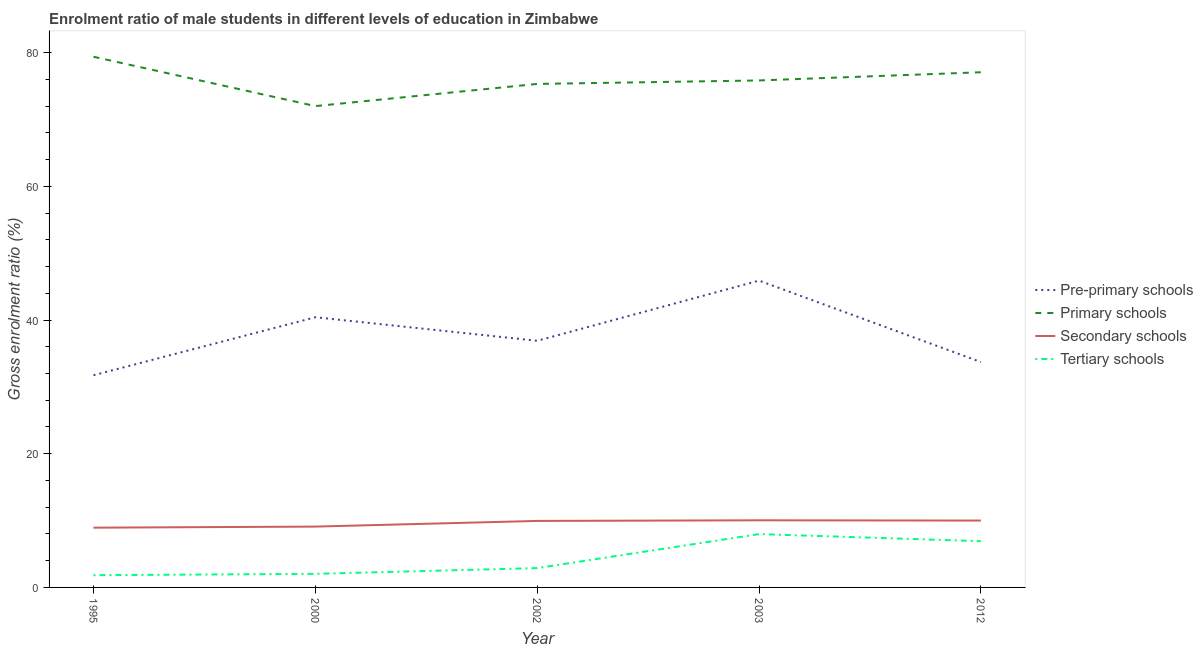How many different coloured lines are there?
Your response must be concise. 4. Is the number of lines equal to the number of legend labels?
Make the answer very short. Yes. What is the gross enrolment ratio(female) in tertiary schools in 2000?
Provide a succinct answer. 2.03. Across all years, what is the maximum gross enrolment ratio(female) in tertiary schools?
Offer a very short reply. 7.98. Across all years, what is the minimum gross enrolment ratio(female) in pre-primary schools?
Ensure brevity in your answer.  31.74. What is the total gross enrolment ratio(female) in secondary schools in the graph?
Offer a very short reply. 48.03. What is the difference between the gross enrolment ratio(female) in secondary schools in 1995 and that in 2012?
Your answer should be compact. -1.06. What is the difference between the gross enrolment ratio(female) in pre-primary schools in 2002 and the gross enrolment ratio(female) in tertiary schools in 2003?
Provide a succinct answer. 28.92. What is the average gross enrolment ratio(female) in secondary schools per year?
Keep it short and to the point. 9.61. In the year 1995, what is the difference between the gross enrolment ratio(female) in secondary schools and gross enrolment ratio(female) in primary schools?
Offer a terse response. -70.44. In how many years, is the gross enrolment ratio(female) in pre-primary schools greater than 28 %?
Keep it short and to the point. 5. What is the ratio of the gross enrolment ratio(female) in pre-primary schools in 2000 to that in 2012?
Your answer should be very brief. 1.2. Is the gross enrolment ratio(female) in primary schools in 2003 less than that in 2012?
Offer a terse response. Yes. Is the difference between the gross enrolment ratio(female) in tertiary schools in 1995 and 2002 greater than the difference between the gross enrolment ratio(female) in pre-primary schools in 1995 and 2002?
Provide a succinct answer. Yes. What is the difference between the highest and the second highest gross enrolment ratio(female) in primary schools?
Provide a short and direct response. 2.32. What is the difference between the highest and the lowest gross enrolment ratio(female) in secondary schools?
Provide a short and direct response. 1.1. In how many years, is the gross enrolment ratio(female) in secondary schools greater than the average gross enrolment ratio(female) in secondary schools taken over all years?
Your answer should be very brief. 3. Is the sum of the gross enrolment ratio(female) in tertiary schools in 2002 and 2003 greater than the maximum gross enrolment ratio(female) in primary schools across all years?
Provide a succinct answer. No. Is it the case that in every year, the sum of the gross enrolment ratio(female) in pre-primary schools and gross enrolment ratio(female) in primary schools is greater than the gross enrolment ratio(female) in secondary schools?
Provide a short and direct response. Yes. Is the gross enrolment ratio(female) in tertiary schools strictly greater than the gross enrolment ratio(female) in primary schools over the years?
Provide a succinct answer. No. How many lines are there?
Make the answer very short. 4. How many years are there in the graph?
Provide a succinct answer. 5. What is the difference between two consecutive major ticks on the Y-axis?
Provide a succinct answer. 20. Does the graph contain any zero values?
Your answer should be very brief. No. Where does the legend appear in the graph?
Ensure brevity in your answer.  Center right. How are the legend labels stacked?
Keep it short and to the point. Vertical. What is the title of the graph?
Keep it short and to the point. Enrolment ratio of male students in different levels of education in Zimbabwe. Does "Budget management" appear as one of the legend labels in the graph?
Ensure brevity in your answer.  No. What is the label or title of the X-axis?
Your response must be concise. Year. What is the label or title of the Y-axis?
Keep it short and to the point. Gross enrolment ratio (%). What is the Gross enrolment ratio (%) in Pre-primary schools in 1995?
Make the answer very short. 31.74. What is the Gross enrolment ratio (%) of Primary schools in 1995?
Ensure brevity in your answer.  79.38. What is the Gross enrolment ratio (%) in Secondary schools in 1995?
Keep it short and to the point. 8.94. What is the Gross enrolment ratio (%) in Tertiary schools in 1995?
Give a very brief answer. 1.83. What is the Gross enrolment ratio (%) of Pre-primary schools in 2000?
Give a very brief answer. 40.42. What is the Gross enrolment ratio (%) of Primary schools in 2000?
Provide a succinct answer. 72. What is the Gross enrolment ratio (%) of Secondary schools in 2000?
Provide a short and direct response. 9.1. What is the Gross enrolment ratio (%) in Tertiary schools in 2000?
Provide a succinct answer. 2.03. What is the Gross enrolment ratio (%) of Pre-primary schools in 2002?
Provide a succinct answer. 36.9. What is the Gross enrolment ratio (%) of Primary schools in 2002?
Your answer should be compact. 75.32. What is the Gross enrolment ratio (%) in Secondary schools in 2002?
Your response must be concise. 9.95. What is the Gross enrolment ratio (%) of Tertiary schools in 2002?
Ensure brevity in your answer.  2.89. What is the Gross enrolment ratio (%) of Pre-primary schools in 2003?
Your response must be concise. 45.9. What is the Gross enrolment ratio (%) of Primary schools in 2003?
Ensure brevity in your answer.  75.84. What is the Gross enrolment ratio (%) of Secondary schools in 2003?
Your response must be concise. 10.04. What is the Gross enrolment ratio (%) in Tertiary schools in 2003?
Give a very brief answer. 7.98. What is the Gross enrolment ratio (%) of Pre-primary schools in 2012?
Ensure brevity in your answer.  33.71. What is the Gross enrolment ratio (%) of Primary schools in 2012?
Offer a very short reply. 77.06. What is the Gross enrolment ratio (%) of Secondary schools in 2012?
Provide a succinct answer. 10. What is the Gross enrolment ratio (%) in Tertiary schools in 2012?
Give a very brief answer. 6.92. Across all years, what is the maximum Gross enrolment ratio (%) of Pre-primary schools?
Offer a very short reply. 45.9. Across all years, what is the maximum Gross enrolment ratio (%) of Primary schools?
Make the answer very short. 79.38. Across all years, what is the maximum Gross enrolment ratio (%) of Secondary schools?
Your answer should be very brief. 10.04. Across all years, what is the maximum Gross enrolment ratio (%) of Tertiary schools?
Ensure brevity in your answer.  7.98. Across all years, what is the minimum Gross enrolment ratio (%) of Pre-primary schools?
Your answer should be compact. 31.74. Across all years, what is the minimum Gross enrolment ratio (%) of Primary schools?
Ensure brevity in your answer.  72. Across all years, what is the minimum Gross enrolment ratio (%) of Secondary schools?
Offer a terse response. 8.94. Across all years, what is the minimum Gross enrolment ratio (%) of Tertiary schools?
Provide a succinct answer. 1.83. What is the total Gross enrolment ratio (%) of Pre-primary schools in the graph?
Keep it short and to the point. 188.66. What is the total Gross enrolment ratio (%) of Primary schools in the graph?
Your answer should be compact. 379.6. What is the total Gross enrolment ratio (%) in Secondary schools in the graph?
Your answer should be compact. 48.03. What is the total Gross enrolment ratio (%) in Tertiary schools in the graph?
Provide a succinct answer. 21.65. What is the difference between the Gross enrolment ratio (%) in Pre-primary schools in 1995 and that in 2000?
Offer a terse response. -8.67. What is the difference between the Gross enrolment ratio (%) of Primary schools in 1995 and that in 2000?
Provide a short and direct response. 7.38. What is the difference between the Gross enrolment ratio (%) of Secondary schools in 1995 and that in 2000?
Ensure brevity in your answer.  -0.16. What is the difference between the Gross enrolment ratio (%) in Tertiary schools in 1995 and that in 2000?
Provide a short and direct response. -0.2. What is the difference between the Gross enrolment ratio (%) in Pre-primary schools in 1995 and that in 2002?
Keep it short and to the point. -5.15. What is the difference between the Gross enrolment ratio (%) of Primary schools in 1995 and that in 2002?
Offer a terse response. 4.06. What is the difference between the Gross enrolment ratio (%) in Secondary schools in 1995 and that in 2002?
Give a very brief answer. -1.01. What is the difference between the Gross enrolment ratio (%) in Tertiary schools in 1995 and that in 2002?
Offer a very short reply. -1.06. What is the difference between the Gross enrolment ratio (%) of Pre-primary schools in 1995 and that in 2003?
Offer a very short reply. -14.15. What is the difference between the Gross enrolment ratio (%) in Primary schools in 1995 and that in 2003?
Keep it short and to the point. 3.55. What is the difference between the Gross enrolment ratio (%) in Secondary schools in 1995 and that in 2003?
Provide a succinct answer. -1.1. What is the difference between the Gross enrolment ratio (%) in Tertiary schools in 1995 and that in 2003?
Your answer should be very brief. -6.15. What is the difference between the Gross enrolment ratio (%) in Pre-primary schools in 1995 and that in 2012?
Give a very brief answer. -1.97. What is the difference between the Gross enrolment ratio (%) in Primary schools in 1995 and that in 2012?
Give a very brief answer. 2.32. What is the difference between the Gross enrolment ratio (%) in Secondary schools in 1995 and that in 2012?
Your answer should be very brief. -1.06. What is the difference between the Gross enrolment ratio (%) of Tertiary schools in 1995 and that in 2012?
Make the answer very short. -5.09. What is the difference between the Gross enrolment ratio (%) of Pre-primary schools in 2000 and that in 2002?
Ensure brevity in your answer.  3.52. What is the difference between the Gross enrolment ratio (%) in Primary schools in 2000 and that in 2002?
Your answer should be compact. -3.32. What is the difference between the Gross enrolment ratio (%) in Secondary schools in 2000 and that in 2002?
Your answer should be compact. -0.85. What is the difference between the Gross enrolment ratio (%) in Tertiary schools in 2000 and that in 2002?
Provide a short and direct response. -0.86. What is the difference between the Gross enrolment ratio (%) of Pre-primary schools in 2000 and that in 2003?
Offer a terse response. -5.48. What is the difference between the Gross enrolment ratio (%) of Primary schools in 2000 and that in 2003?
Your answer should be compact. -3.84. What is the difference between the Gross enrolment ratio (%) of Secondary schools in 2000 and that in 2003?
Keep it short and to the point. -0.94. What is the difference between the Gross enrolment ratio (%) in Tertiary schools in 2000 and that in 2003?
Make the answer very short. -5.94. What is the difference between the Gross enrolment ratio (%) in Pre-primary schools in 2000 and that in 2012?
Your response must be concise. 6.7. What is the difference between the Gross enrolment ratio (%) of Primary schools in 2000 and that in 2012?
Your answer should be very brief. -5.06. What is the difference between the Gross enrolment ratio (%) in Secondary schools in 2000 and that in 2012?
Your response must be concise. -0.9. What is the difference between the Gross enrolment ratio (%) in Tertiary schools in 2000 and that in 2012?
Your answer should be compact. -4.88. What is the difference between the Gross enrolment ratio (%) of Pre-primary schools in 2002 and that in 2003?
Provide a short and direct response. -9. What is the difference between the Gross enrolment ratio (%) of Primary schools in 2002 and that in 2003?
Offer a very short reply. -0.52. What is the difference between the Gross enrolment ratio (%) in Secondary schools in 2002 and that in 2003?
Your answer should be compact. -0.09. What is the difference between the Gross enrolment ratio (%) in Tertiary schools in 2002 and that in 2003?
Your answer should be very brief. -5.09. What is the difference between the Gross enrolment ratio (%) of Pre-primary schools in 2002 and that in 2012?
Your answer should be compact. 3.18. What is the difference between the Gross enrolment ratio (%) in Primary schools in 2002 and that in 2012?
Offer a terse response. -1.74. What is the difference between the Gross enrolment ratio (%) in Secondary schools in 2002 and that in 2012?
Your answer should be compact. -0.06. What is the difference between the Gross enrolment ratio (%) in Tertiary schools in 2002 and that in 2012?
Provide a short and direct response. -4.03. What is the difference between the Gross enrolment ratio (%) of Pre-primary schools in 2003 and that in 2012?
Keep it short and to the point. 12.18. What is the difference between the Gross enrolment ratio (%) in Primary schools in 2003 and that in 2012?
Your response must be concise. -1.23. What is the difference between the Gross enrolment ratio (%) in Secondary schools in 2003 and that in 2012?
Your answer should be very brief. 0.04. What is the difference between the Gross enrolment ratio (%) of Tertiary schools in 2003 and that in 2012?
Keep it short and to the point. 1.06. What is the difference between the Gross enrolment ratio (%) in Pre-primary schools in 1995 and the Gross enrolment ratio (%) in Primary schools in 2000?
Offer a very short reply. -40.26. What is the difference between the Gross enrolment ratio (%) of Pre-primary schools in 1995 and the Gross enrolment ratio (%) of Secondary schools in 2000?
Provide a short and direct response. 22.64. What is the difference between the Gross enrolment ratio (%) of Pre-primary schools in 1995 and the Gross enrolment ratio (%) of Tertiary schools in 2000?
Your response must be concise. 29.71. What is the difference between the Gross enrolment ratio (%) of Primary schools in 1995 and the Gross enrolment ratio (%) of Secondary schools in 2000?
Provide a short and direct response. 70.28. What is the difference between the Gross enrolment ratio (%) in Primary schools in 1995 and the Gross enrolment ratio (%) in Tertiary schools in 2000?
Provide a short and direct response. 77.35. What is the difference between the Gross enrolment ratio (%) in Secondary schools in 1995 and the Gross enrolment ratio (%) in Tertiary schools in 2000?
Provide a short and direct response. 6.91. What is the difference between the Gross enrolment ratio (%) of Pre-primary schools in 1995 and the Gross enrolment ratio (%) of Primary schools in 2002?
Provide a succinct answer. -43.58. What is the difference between the Gross enrolment ratio (%) in Pre-primary schools in 1995 and the Gross enrolment ratio (%) in Secondary schools in 2002?
Your answer should be very brief. 21.8. What is the difference between the Gross enrolment ratio (%) of Pre-primary schools in 1995 and the Gross enrolment ratio (%) of Tertiary schools in 2002?
Your response must be concise. 28.85. What is the difference between the Gross enrolment ratio (%) in Primary schools in 1995 and the Gross enrolment ratio (%) in Secondary schools in 2002?
Provide a short and direct response. 69.44. What is the difference between the Gross enrolment ratio (%) in Primary schools in 1995 and the Gross enrolment ratio (%) in Tertiary schools in 2002?
Provide a succinct answer. 76.49. What is the difference between the Gross enrolment ratio (%) of Secondary schools in 1995 and the Gross enrolment ratio (%) of Tertiary schools in 2002?
Provide a short and direct response. 6.05. What is the difference between the Gross enrolment ratio (%) of Pre-primary schools in 1995 and the Gross enrolment ratio (%) of Primary schools in 2003?
Your response must be concise. -44.09. What is the difference between the Gross enrolment ratio (%) in Pre-primary schools in 1995 and the Gross enrolment ratio (%) in Secondary schools in 2003?
Your answer should be compact. 21.7. What is the difference between the Gross enrolment ratio (%) in Pre-primary schools in 1995 and the Gross enrolment ratio (%) in Tertiary schools in 2003?
Provide a succinct answer. 23.77. What is the difference between the Gross enrolment ratio (%) of Primary schools in 1995 and the Gross enrolment ratio (%) of Secondary schools in 2003?
Your answer should be compact. 69.34. What is the difference between the Gross enrolment ratio (%) in Primary schools in 1995 and the Gross enrolment ratio (%) in Tertiary schools in 2003?
Your answer should be very brief. 71.41. What is the difference between the Gross enrolment ratio (%) of Secondary schools in 1995 and the Gross enrolment ratio (%) of Tertiary schools in 2003?
Offer a terse response. 0.96. What is the difference between the Gross enrolment ratio (%) of Pre-primary schools in 1995 and the Gross enrolment ratio (%) of Primary schools in 2012?
Offer a very short reply. -45.32. What is the difference between the Gross enrolment ratio (%) in Pre-primary schools in 1995 and the Gross enrolment ratio (%) in Secondary schools in 2012?
Ensure brevity in your answer.  21.74. What is the difference between the Gross enrolment ratio (%) in Pre-primary schools in 1995 and the Gross enrolment ratio (%) in Tertiary schools in 2012?
Your answer should be very brief. 24.83. What is the difference between the Gross enrolment ratio (%) of Primary schools in 1995 and the Gross enrolment ratio (%) of Secondary schools in 2012?
Ensure brevity in your answer.  69.38. What is the difference between the Gross enrolment ratio (%) of Primary schools in 1995 and the Gross enrolment ratio (%) of Tertiary schools in 2012?
Your answer should be very brief. 72.47. What is the difference between the Gross enrolment ratio (%) of Secondary schools in 1995 and the Gross enrolment ratio (%) of Tertiary schools in 2012?
Offer a terse response. 2.02. What is the difference between the Gross enrolment ratio (%) of Pre-primary schools in 2000 and the Gross enrolment ratio (%) of Primary schools in 2002?
Your answer should be very brief. -34.9. What is the difference between the Gross enrolment ratio (%) in Pre-primary schools in 2000 and the Gross enrolment ratio (%) in Secondary schools in 2002?
Provide a short and direct response. 30.47. What is the difference between the Gross enrolment ratio (%) of Pre-primary schools in 2000 and the Gross enrolment ratio (%) of Tertiary schools in 2002?
Keep it short and to the point. 37.52. What is the difference between the Gross enrolment ratio (%) of Primary schools in 2000 and the Gross enrolment ratio (%) of Secondary schools in 2002?
Provide a succinct answer. 62.05. What is the difference between the Gross enrolment ratio (%) of Primary schools in 2000 and the Gross enrolment ratio (%) of Tertiary schools in 2002?
Offer a very short reply. 69.11. What is the difference between the Gross enrolment ratio (%) in Secondary schools in 2000 and the Gross enrolment ratio (%) in Tertiary schools in 2002?
Your response must be concise. 6.21. What is the difference between the Gross enrolment ratio (%) in Pre-primary schools in 2000 and the Gross enrolment ratio (%) in Primary schools in 2003?
Provide a short and direct response. -35.42. What is the difference between the Gross enrolment ratio (%) in Pre-primary schools in 2000 and the Gross enrolment ratio (%) in Secondary schools in 2003?
Provide a succinct answer. 30.37. What is the difference between the Gross enrolment ratio (%) of Pre-primary schools in 2000 and the Gross enrolment ratio (%) of Tertiary schools in 2003?
Your response must be concise. 32.44. What is the difference between the Gross enrolment ratio (%) of Primary schools in 2000 and the Gross enrolment ratio (%) of Secondary schools in 2003?
Ensure brevity in your answer.  61.96. What is the difference between the Gross enrolment ratio (%) in Primary schools in 2000 and the Gross enrolment ratio (%) in Tertiary schools in 2003?
Provide a succinct answer. 64.02. What is the difference between the Gross enrolment ratio (%) in Secondary schools in 2000 and the Gross enrolment ratio (%) in Tertiary schools in 2003?
Make the answer very short. 1.12. What is the difference between the Gross enrolment ratio (%) of Pre-primary schools in 2000 and the Gross enrolment ratio (%) of Primary schools in 2012?
Your answer should be compact. -36.65. What is the difference between the Gross enrolment ratio (%) in Pre-primary schools in 2000 and the Gross enrolment ratio (%) in Secondary schools in 2012?
Make the answer very short. 30.41. What is the difference between the Gross enrolment ratio (%) of Pre-primary schools in 2000 and the Gross enrolment ratio (%) of Tertiary schools in 2012?
Your answer should be compact. 33.5. What is the difference between the Gross enrolment ratio (%) of Primary schools in 2000 and the Gross enrolment ratio (%) of Secondary schools in 2012?
Your answer should be compact. 62. What is the difference between the Gross enrolment ratio (%) of Primary schools in 2000 and the Gross enrolment ratio (%) of Tertiary schools in 2012?
Your answer should be compact. 65.08. What is the difference between the Gross enrolment ratio (%) in Secondary schools in 2000 and the Gross enrolment ratio (%) in Tertiary schools in 2012?
Keep it short and to the point. 2.18. What is the difference between the Gross enrolment ratio (%) of Pre-primary schools in 2002 and the Gross enrolment ratio (%) of Primary schools in 2003?
Your answer should be compact. -38.94. What is the difference between the Gross enrolment ratio (%) of Pre-primary schools in 2002 and the Gross enrolment ratio (%) of Secondary schools in 2003?
Provide a short and direct response. 26.86. What is the difference between the Gross enrolment ratio (%) of Pre-primary schools in 2002 and the Gross enrolment ratio (%) of Tertiary schools in 2003?
Keep it short and to the point. 28.92. What is the difference between the Gross enrolment ratio (%) in Primary schools in 2002 and the Gross enrolment ratio (%) in Secondary schools in 2003?
Offer a very short reply. 65.28. What is the difference between the Gross enrolment ratio (%) in Primary schools in 2002 and the Gross enrolment ratio (%) in Tertiary schools in 2003?
Offer a very short reply. 67.34. What is the difference between the Gross enrolment ratio (%) of Secondary schools in 2002 and the Gross enrolment ratio (%) of Tertiary schools in 2003?
Your answer should be very brief. 1.97. What is the difference between the Gross enrolment ratio (%) of Pre-primary schools in 2002 and the Gross enrolment ratio (%) of Primary schools in 2012?
Offer a terse response. -40.17. What is the difference between the Gross enrolment ratio (%) of Pre-primary schools in 2002 and the Gross enrolment ratio (%) of Secondary schools in 2012?
Your answer should be compact. 26.89. What is the difference between the Gross enrolment ratio (%) in Pre-primary schools in 2002 and the Gross enrolment ratio (%) in Tertiary schools in 2012?
Make the answer very short. 29.98. What is the difference between the Gross enrolment ratio (%) in Primary schools in 2002 and the Gross enrolment ratio (%) in Secondary schools in 2012?
Your response must be concise. 65.32. What is the difference between the Gross enrolment ratio (%) of Primary schools in 2002 and the Gross enrolment ratio (%) of Tertiary schools in 2012?
Make the answer very short. 68.4. What is the difference between the Gross enrolment ratio (%) in Secondary schools in 2002 and the Gross enrolment ratio (%) in Tertiary schools in 2012?
Your answer should be compact. 3.03. What is the difference between the Gross enrolment ratio (%) in Pre-primary schools in 2003 and the Gross enrolment ratio (%) in Primary schools in 2012?
Your answer should be compact. -31.17. What is the difference between the Gross enrolment ratio (%) of Pre-primary schools in 2003 and the Gross enrolment ratio (%) of Secondary schools in 2012?
Your answer should be compact. 35.89. What is the difference between the Gross enrolment ratio (%) in Pre-primary schools in 2003 and the Gross enrolment ratio (%) in Tertiary schools in 2012?
Your response must be concise. 38.98. What is the difference between the Gross enrolment ratio (%) in Primary schools in 2003 and the Gross enrolment ratio (%) in Secondary schools in 2012?
Your answer should be compact. 65.83. What is the difference between the Gross enrolment ratio (%) of Primary schools in 2003 and the Gross enrolment ratio (%) of Tertiary schools in 2012?
Offer a terse response. 68.92. What is the difference between the Gross enrolment ratio (%) in Secondary schools in 2003 and the Gross enrolment ratio (%) in Tertiary schools in 2012?
Your response must be concise. 3.12. What is the average Gross enrolment ratio (%) of Pre-primary schools per year?
Your answer should be very brief. 37.73. What is the average Gross enrolment ratio (%) of Primary schools per year?
Provide a short and direct response. 75.92. What is the average Gross enrolment ratio (%) in Secondary schools per year?
Your answer should be compact. 9.61. What is the average Gross enrolment ratio (%) in Tertiary schools per year?
Your answer should be compact. 4.33. In the year 1995, what is the difference between the Gross enrolment ratio (%) in Pre-primary schools and Gross enrolment ratio (%) in Primary schools?
Your answer should be compact. -47.64. In the year 1995, what is the difference between the Gross enrolment ratio (%) in Pre-primary schools and Gross enrolment ratio (%) in Secondary schools?
Keep it short and to the point. 22.8. In the year 1995, what is the difference between the Gross enrolment ratio (%) of Pre-primary schools and Gross enrolment ratio (%) of Tertiary schools?
Offer a very short reply. 29.91. In the year 1995, what is the difference between the Gross enrolment ratio (%) of Primary schools and Gross enrolment ratio (%) of Secondary schools?
Provide a succinct answer. 70.44. In the year 1995, what is the difference between the Gross enrolment ratio (%) of Primary schools and Gross enrolment ratio (%) of Tertiary schools?
Your answer should be compact. 77.55. In the year 1995, what is the difference between the Gross enrolment ratio (%) of Secondary schools and Gross enrolment ratio (%) of Tertiary schools?
Your answer should be compact. 7.11. In the year 2000, what is the difference between the Gross enrolment ratio (%) of Pre-primary schools and Gross enrolment ratio (%) of Primary schools?
Your response must be concise. -31.59. In the year 2000, what is the difference between the Gross enrolment ratio (%) of Pre-primary schools and Gross enrolment ratio (%) of Secondary schools?
Keep it short and to the point. 31.31. In the year 2000, what is the difference between the Gross enrolment ratio (%) of Pre-primary schools and Gross enrolment ratio (%) of Tertiary schools?
Provide a succinct answer. 38.38. In the year 2000, what is the difference between the Gross enrolment ratio (%) in Primary schools and Gross enrolment ratio (%) in Secondary schools?
Offer a terse response. 62.9. In the year 2000, what is the difference between the Gross enrolment ratio (%) in Primary schools and Gross enrolment ratio (%) in Tertiary schools?
Your response must be concise. 69.97. In the year 2000, what is the difference between the Gross enrolment ratio (%) in Secondary schools and Gross enrolment ratio (%) in Tertiary schools?
Make the answer very short. 7.07. In the year 2002, what is the difference between the Gross enrolment ratio (%) in Pre-primary schools and Gross enrolment ratio (%) in Primary schools?
Provide a short and direct response. -38.42. In the year 2002, what is the difference between the Gross enrolment ratio (%) in Pre-primary schools and Gross enrolment ratio (%) in Secondary schools?
Keep it short and to the point. 26.95. In the year 2002, what is the difference between the Gross enrolment ratio (%) in Pre-primary schools and Gross enrolment ratio (%) in Tertiary schools?
Offer a terse response. 34.01. In the year 2002, what is the difference between the Gross enrolment ratio (%) in Primary schools and Gross enrolment ratio (%) in Secondary schools?
Make the answer very short. 65.37. In the year 2002, what is the difference between the Gross enrolment ratio (%) in Primary schools and Gross enrolment ratio (%) in Tertiary schools?
Your answer should be compact. 72.43. In the year 2002, what is the difference between the Gross enrolment ratio (%) in Secondary schools and Gross enrolment ratio (%) in Tertiary schools?
Make the answer very short. 7.06. In the year 2003, what is the difference between the Gross enrolment ratio (%) in Pre-primary schools and Gross enrolment ratio (%) in Primary schools?
Keep it short and to the point. -29.94. In the year 2003, what is the difference between the Gross enrolment ratio (%) of Pre-primary schools and Gross enrolment ratio (%) of Secondary schools?
Provide a short and direct response. 35.85. In the year 2003, what is the difference between the Gross enrolment ratio (%) of Pre-primary schools and Gross enrolment ratio (%) of Tertiary schools?
Your answer should be very brief. 37.92. In the year 2003, what is the difference between the Gross enrolment ratio (%) of Primary schools and Gross enrolment ratio (%) of Secondary schools?
Your answer should be compact. 65.8. In the year 2003, what is the difference between the Gross enrolment ratio (%) in Primary schools and Gross enrolment ratio (%) in Tertiary schools?
Your response must be concise. 67.86. In the year 2003, what is the difference between the Gross enrolment ratio (%) of Secondary schools and Gross enrolment ratio (%) of Tertiary schools?
Your answer should be compact. 2.06. In the year 2012, what is the difference between the Gross enrolment ratio (%) of Pre-primary schools and Gross enrolment ratio (%) of Primary schools?
Your answer should be compact. -43.35. In the year 2012, what is the difference between the Gross enrolment ratio (%) in Pre-primary schools and Gross enrolment ratio (%) in Secondary schools?
Provide a short and direct response. 23.71. In the year 2012, what is the difference between the Gross enrolment ratio (%) of Pre-primary schools and Gross enrolment ratio (%) of Tertiary schools?
Keep it short and to the point. 26.8. In the year 2012, what is the difference between the Gross enrolment ratio (%) in Primary schools and Gross enrolment ratio (%) in Secondary schools?
Give a very brief answer. 67.06. In the year 2012, what is the difference between the Gross enrolment ratio (%) in Primary schools and Gross enrolment ratio (%) in Tertiary schools?
Your response must be concise. 70.15. In the year 2012, what is the difference between the Gross enrolment ratio (%) in Secondary schools and Gross enrolment ratio (%) in Tertiary schools?
Your answer should be very brief. 3.09. What is the ratio of the Gross enrolment ratio (%) of Pre-primary schools in 1995 to that in 2000?
Give a very brief answer. 0.79. What is the ratio of the Gross enrolment ratio (%) of Primary schools in 1995 to that in 2000?
Your response must be concise. 1.1. What is the ratio of the Gross enrolment ratio (%) in Secondary schools in 1995 to that in 2000?
Offer a terse response. 0.98. What is the ratio of the Gross enrolment ratio (%) in Tertiary schools in 1995 to that in 2000?
Your response must be concise. 0.9. What is the ratio of the Gross enrolment ratio (%) of Pre-primary schools in 1995 to that in 2002?
Offer a very short reply. 0.86. What is the ratio of the Gross enrolment ratio (%) of Primary schools in 1995 to that in 2002?
Offer a terse response. 1.05. What is the ratio of the Gross enrolment ratio (%) of Secondary schools in 1995 to that in 2002?
Ensure brevity in your answer.  0.9. What is the ratio of the Gross enrolment ratio (%) in Tertiary schools in 1995 to that in 2002?
Give a very brief answer. 0.63. What is the ratio of the Gross enrolment ratio (%) in Pre-primary schools in 1995 to that in 2003?
Your response must be concise. 0.69. What is the ratio of the Gross enrolment ratio (%) of Primary schools in 1995 to that in 2003?
Your response must be concise. 1.05. What is the ratio of the Gross enrolment ratio (%) of Secondary schools in 1995 to that in 2003?
Provide a succinct answer. 0.89. What is the ratio of the Gross enrolment ratio (%) in Tertiary schools in 1995 to that in 2003?
Give a very brief answer. 0.23. What is the ratio of the Gross enrolment ratio (%) in Pre-primary schools in 1995 to that in 2012?
Your response must be concise. 0.94. What is the ratio of the Gross enrolment ratio (%) in Primary schools in 1995 to that in 2012?
Provide a succinct answer. 1.03. What is the ratio of the Gross enrolment ratio (%) of Secondary schools in 1995 to that in 2012?
Keep it short and to the point. 0.89. What is the ratio of the Gross enrolment ratio (%) of Tertiary schools in 1995 to that in 2012?
Your response must be concise. 0.26. What is the ratio of the Gross enrolment ratio (%) in Pre-primary schools in 2000 to that in 2002?
Offer a terse response. 1.1. What is the ratio of the Gross enrolment ratio (%) in Primary schools in 2000 to that in 2002?
Your response must be concise. 0.96. What is the ratio of the Gross enrolment ratio (%) of Secondary schools in 2000 to that in 2002?
Make the answer very short. 0.91. What is the ratio of the Gross enrolment ratio (%) of Tertiary schools in 2000 to that in 2002?
Offer a terse response. 0.7. What is the ratio of the Gross enrolment ratio (%) of Pre-primary schools in 2000 to that in 2003?
Give a very brief answer. 0.88. What is the ratio of the Gross enrolment ratio (%) of Primary schools in 2000 to that in 2003?
Your answer should be very brief. 0.95. What is the ratio of the Gross enrolment ratio (%) in Secondary schools in 2000 to that in 2003?
Offer a terse response. 0.91. What is the ratio of the Gross enrolment ratio (%) of Tertiary schools in 2000 to that in 2003?
Keep it short and to the point. 0.25. What is the ratio of the Gross enrolment ratio (%) of Pre-primary schools in 2000 to that in 2012?
Your response must be concise. 1.2. What is the ratio of the Gross enrolment ratio (%) in Primary schools in 2000 to that in 2012?
Your response must be concise. 0.93. What is the ratio of the Gross enrolment ratio (%) in Secondary schools in 2000 to that in 2012?
Give a very brief answer. 0.91. What is the ratio of the Gross enrolment ratio (%) of Tertiary schools in 2000 to that in 2012?
Give a very brief answer. 0.29. What is the ratio of the Gross enrolment ratio (%) of Pre-primary schools in 2002 to that in 2003?
Make the answer very short. 0.8. What is the ratio of the Gross enrolment ratio (%) of Secondary schools in 2002 to that in 2003?
Your answer should be very brief. 0.99. What is the ratio of the Gross enrolment ratio (%) in Tertiary schools in 2002 to that in 2003?
Offer a very short reply. 0.36. What is the ratio of the Gross enrolment ratio (%) in Pre-primary schools in 2002 to that in 2012?
Offer a very short reply. 1.09. What is the ratio of the Gross enrolment ratio (%) in Primary schools in 2002 to that in 2012?
Your response must be concise. 0.98. What is the ratio of the Gross enrolment ratio (%) in Secondary schools in 2002 to that in 2012?
Provide a succinct answer. 0.99. What is the ratio of the Gross enrolment ratio (%) of Tertiary schools in 2002 to that in 2012?
Offer a terse response. 0.42. What is the ratio of the Gross enrolment ratio (%) in Pre-primary schools in 2003 to that in 2012?
Provide a short and direct response. 1.36. What is the ratio of the Gross enrolment ratio (%) in Primary schools in 2003 to that in 2012?
Provide a short and direct response. 0.98. What is the ratio of the Gross enrolment ratio (%) in Tertiary schools in 2003 to that in 2012?
Your answer should be compact. 1.15. What is the difference between the highest and the second highest Gross enrolment ratio (%) in Pre-primary schools?
Keep it short and to the point. 5.48. What is the difference between the highest and the second highest Gross enrolment ratio (%) of Primary schools?
Your response must be concise. 2.32. What is the difference between the highest and the second highest Gross enrolment ratio (%) of Secondary schools?
Your response must be concise. 0.04. What is the difference between the highest and the second highest Gross enrolment ratio (%) in Tertiary schools?
Provide a succinct answer. 1.06. What is the difference between the highest and the lowest Gross enrolment ratio (%) in Pre-primary schools?
Offer a terse response. 14.15. What is the difference between the highest and the lowest Gross enrolment ratio (%) in Primary schools?
Ensure brevity in your answer.  7.38. What is the difference between the highest and the lowest Gross enrolment ratio (%) of Secondary schools?
Your answer should be compact. 1.1. What is the difference between the highest and the lowest Gross enrolment ratio (%) of Tertiary schools?
Make the answer very short. 6.15. 